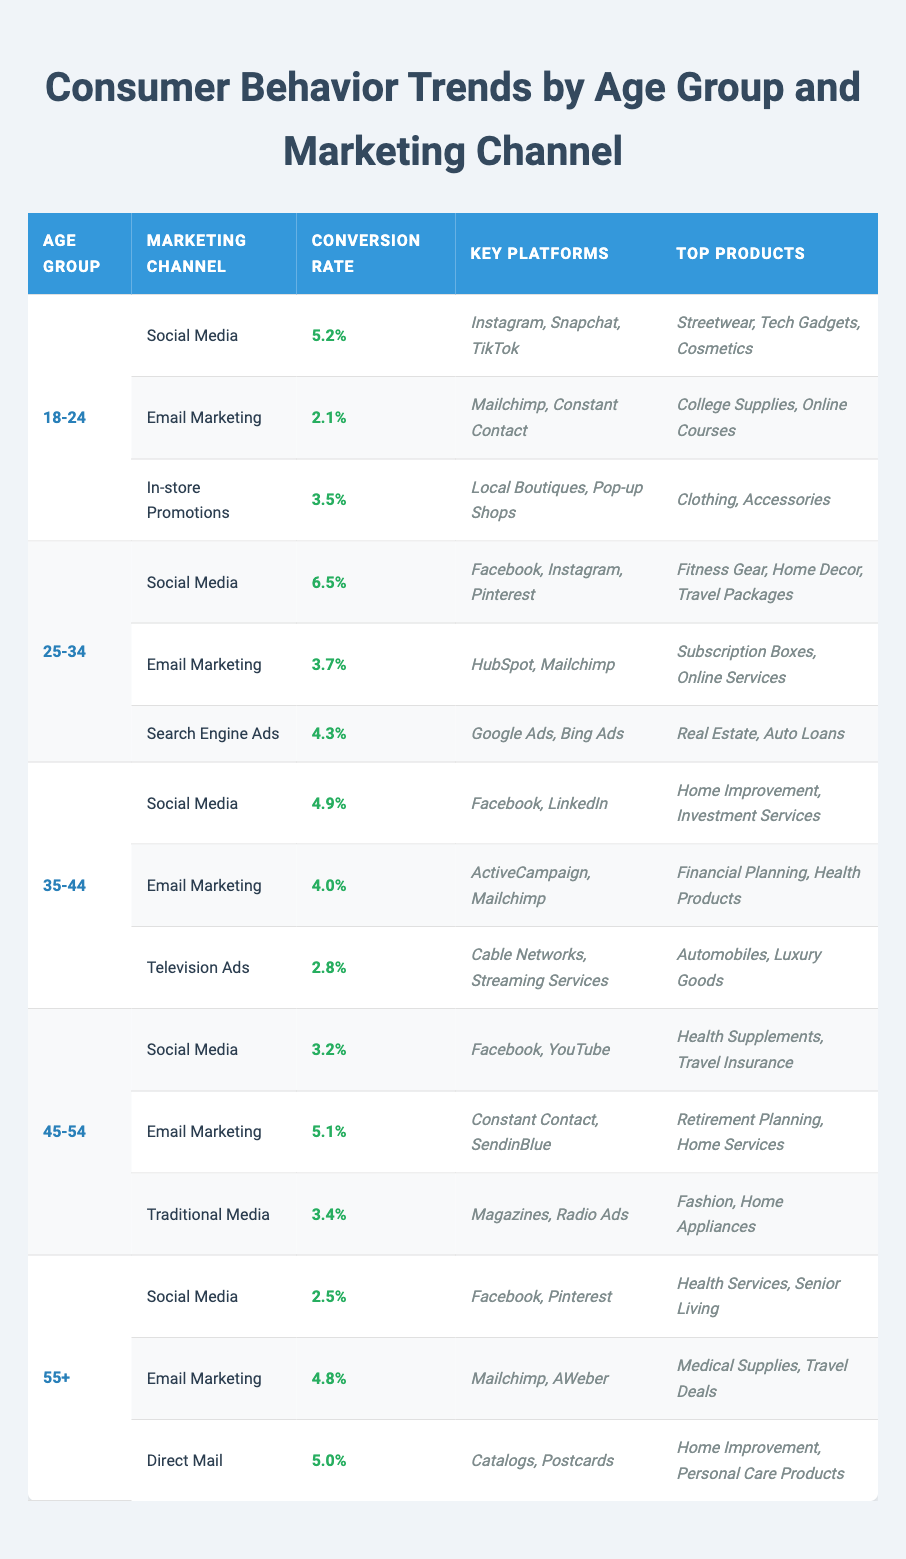What is the conversion rate for social media in the 25-34 age group? The table shows the conversion rates by age group and marketing channels. Looking under the 25-34 age group for the Social Media channel, I see that the conversion rate is 6.5%.
Answer: 6.5% Which marketing channel has the highest conversion rate for the 18-24 age group? In the 18-24 age group, there are three marketing channels listed: Social Media (5.2%), Email Marketing (2.1%), and In-store Promotions (3.5%). The highest conversion rate among these is for Social Media at 5.2%.
Answer: Social Media Is the conversion rate for email marketing in the 35-44 age group greater than 4%? The conversion rate for Email Marketing in the 35-44 age group is 4.0%. Since 4.0% is equal to 4% and not greater than 4%, the answer is no.
Answer: No What is the average conversion rate for social media across all age groups? The conversion rates for social media are 5.2% (18-24), 6.5% (25-34), 4.9% (35-44), 3.2% (45-54), and 2.5% (55+). Adding these rates gives 5.2 + 6.5 + 4.9 + 3.2 + 2.5 = 22.3%. Dividing by 5 (the number of age groups) gives an average of 22.3% / 5 = 4.46%.
Answer: 4.46% For the 45-54 age group, which marketing channel has the lowest conversion rate? The 45-54 age group has Social Media (3.2%), Email Marketing (5.1%), and Traditional Media (3.4%). Comparing these, Social Media has the lowest conversion rate at 3.2%.
Answer: Social Media How does the conversion rate for email marketing in the 25-34 age group compare to that of the 45-54 age group? The conversion rate for Email Marketing in the 25-34 age group is 3.7% and in the 45-54 age group, it is 5.1%. Since 3.7% is less than 5.1%, the conversion rate for the 25-34 age group is lower.
Answer: Lower What are the top three products targeted through social media for the 18-24 age group? The table specifies the top products targeted through Social Media for the 18-24 age group as Streetwear, Tech Gadgets, and Cosmetics.
Answer: Streetwear, Tech Gadgets, Cosmetics Is the conversion rate for direct mail in the 55+ age group higher than for social media in the same age group? The conversion rate for Direct Mail in the 55+ age group is 5.0% and for Social Media it is 2.5%. Since 5.0% is higher than 2.5%, the statement is true.
Answer: Yes 